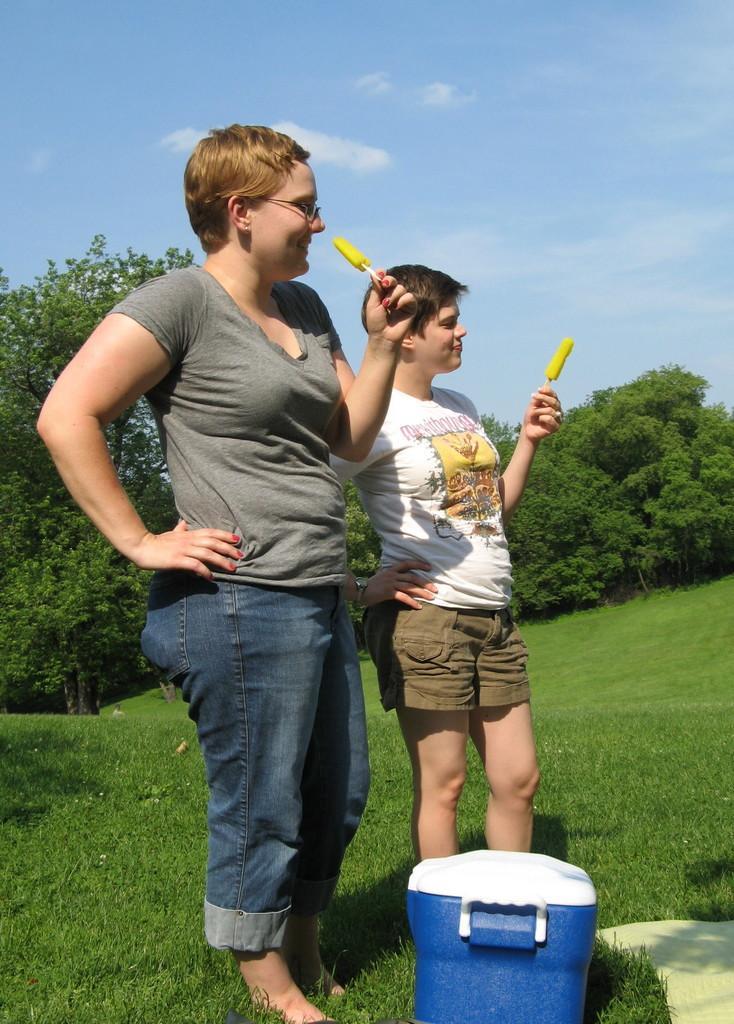Can you describe this image briefly? In this picture, we can see there are two women holding food items and standing on the grass. There is an esky on the grass. Behind the women, there are trees and the sky. 